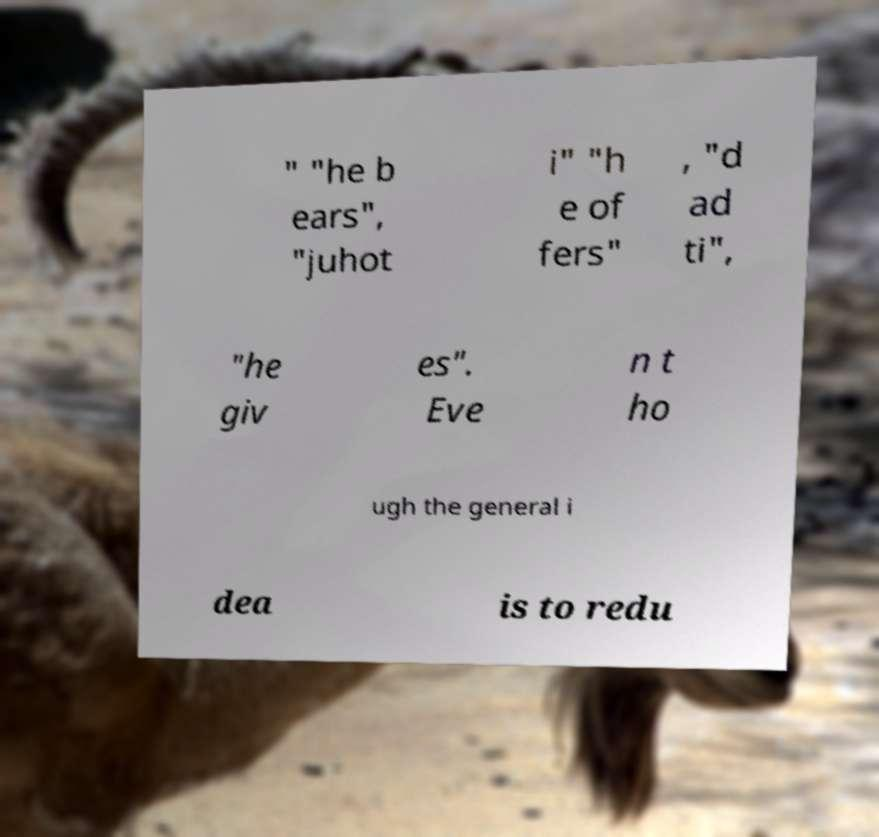Please read and relay the text visible in this image. What does it say? " "he b ears", "juhot i" "h e of fers" , "d ad ti", "he giv es". Eve n t ho ugh the general i dea is to redu 